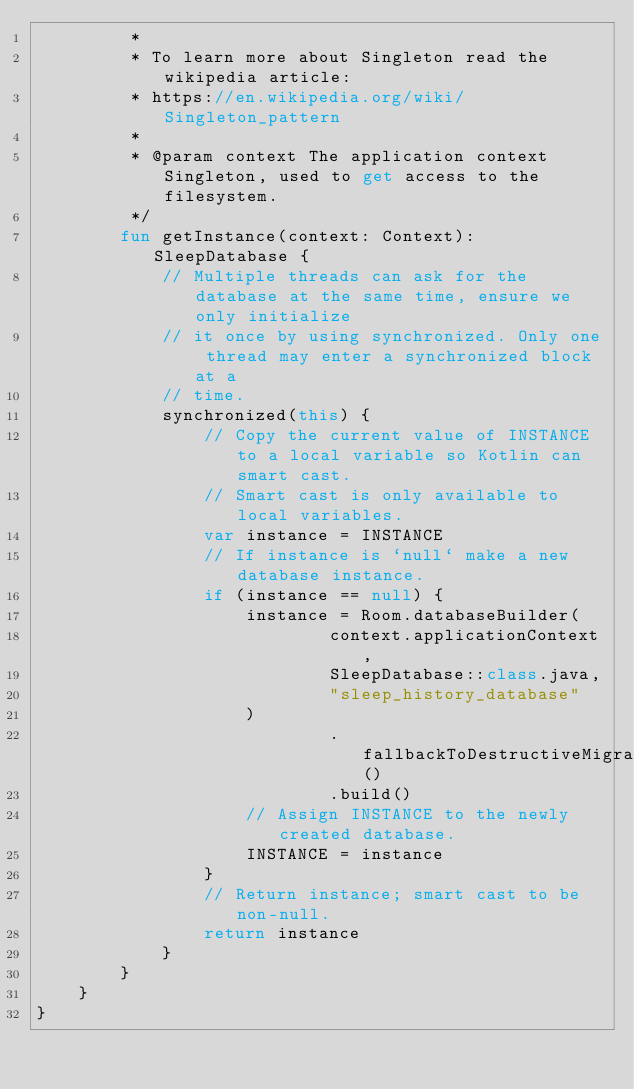Convert code to text. <code><loc_0><loc_0><loc_500><loc_500><_Kotlin_>         *
         * To learn more about Singleton read the wikipedia article:
         * https://en.wikipedia.org/wiki/Singleton_pattern
         *
         * @param context The application context Singleton, used to get access to the filesystem.
         */
        fun getInstance(context: Context): SleepDatabase {
            // Multiple threads can ask for the database at the same time, ensure we only initialize
            // it once by using synchronized. Only one thread may enter a synchronized block at a
            // time.
            synchronized(this) {
                // Copy the current value of INSTANCE to a local variable so Kotlin can smart cast.
                // Smart cast is only available to local variables.
                var instance = INSTANCE
                // If instance is `null` make a new database instance.
                if (instance == null) {
                    instance = Room.databaseBuilder(
                            context.applicationContext,
                            SleepDatabase::class.java,
                            "sleep_history_database"
                    )
                            .fallbackToDestructiveMigration()
                            .build()
                    // Assign INSTANCE to the newly created database.
                    INSTANCE = instance
                }
                // Return instance; smart cast to be non-null.
                return instance
            }
        }
    }
}
</code> 